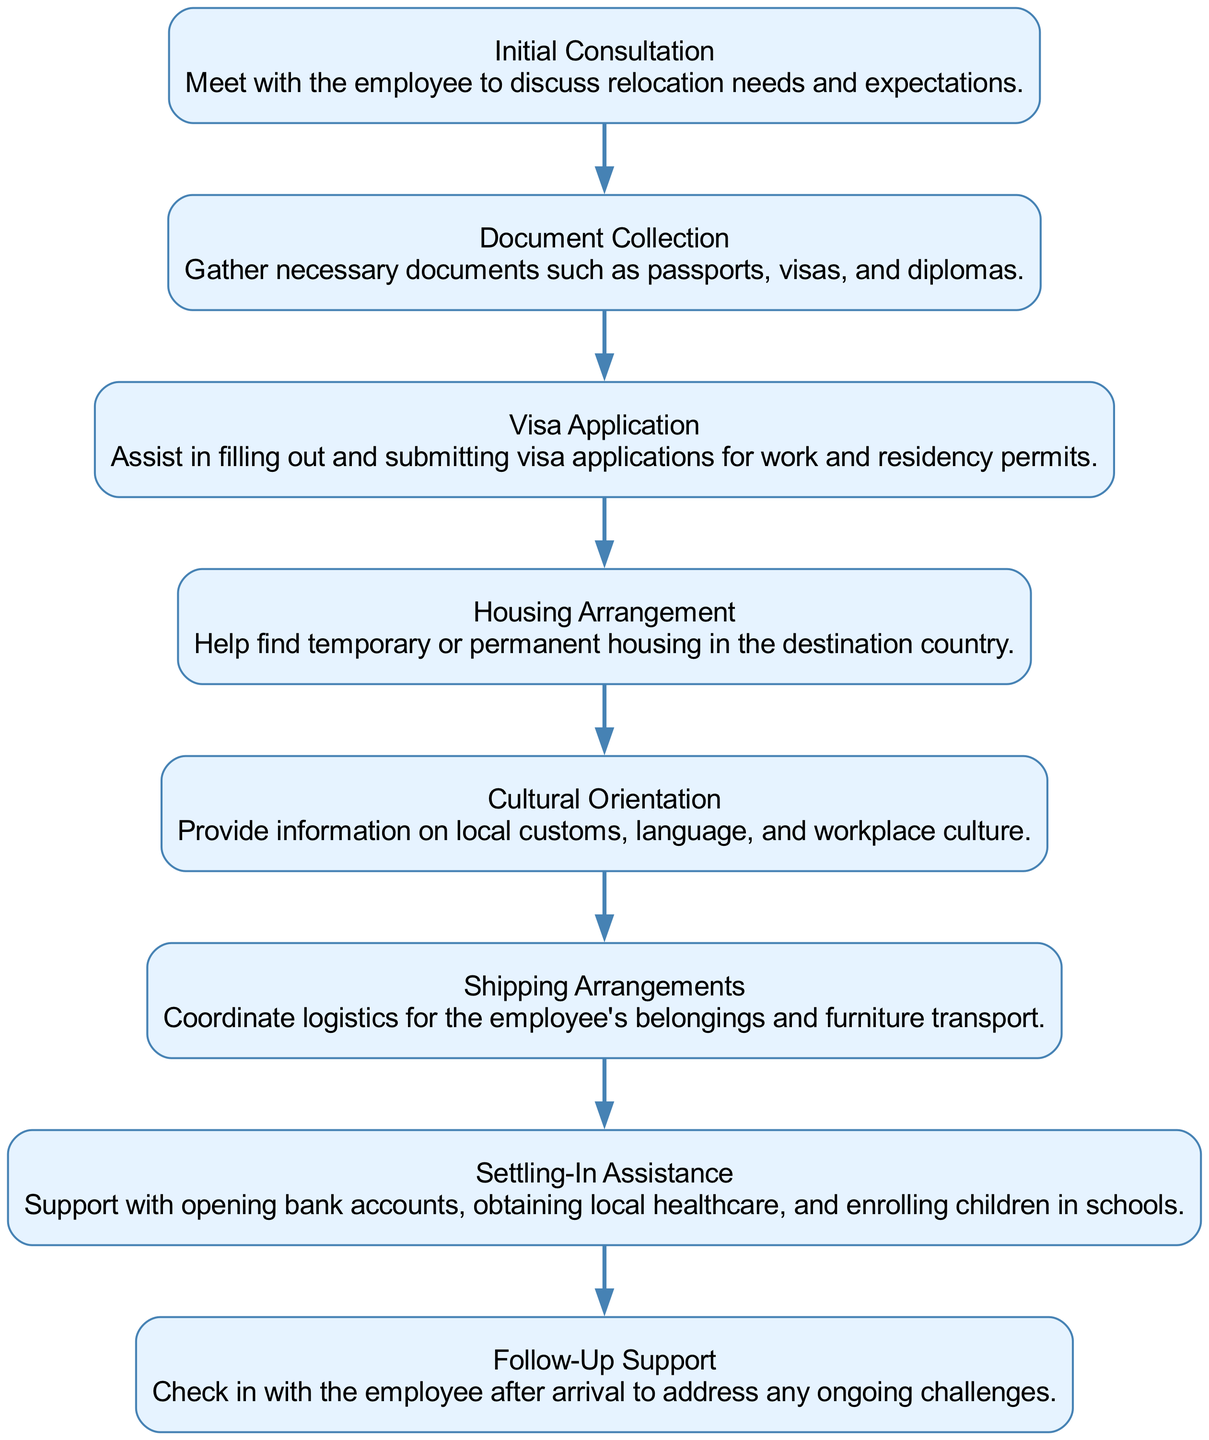What is the first step in the relocation process pipeline? The diagram starts with the first node labeled "Initial Consultation." This is the first step listed in the relocation process.
Answer: Initial Consultation How many total steps are in the relocation process? By counting the nodes in the diagram, we find there are eight distinct steps listed, from "Initial Consultation" to "Follow-Up Support."
Answer: 8 Which step follows the "Visa Application"? In the diagram, the "Visa Application" step is connected to the next node labeled "Housing Arrangement." This indicates the sequential flow of the process.
Answer: Housing Arrangement What is included in the "Settling-In Assistance"? The description under the "Settling-In Assistance" node mentions supporting opening bank accounts, obtaining local healthcare, and enrolling children in schools. Therefore, it includes several essential services for the employee.
Answer: Opening bank accounts, obtaining local healthcare, enrolling in schools What is the last step of the relocation process pipeline? Looking at the final node in the diagram, we see it is labeled "Follow-Up Support," indicating that this is where the process concludes.
Answer: Follow-Up Support What step provides cultural information about the destination? Reviewing the nodes, the "Cultural Orientation" step is specifically designed to provide information about local customs, language, and workplace culture, according to the description.
Answer: Cultural Orientation Which step assists with logistics for the employee's belongings? The diagram identifies the "Shipping Arrangements" step as the one coordinating logistics for transporting the employee's belongings and furniture, based on its label and description.
Answer: Shipping Arrangements Is there any step that provides ongoing support after arrival? The diagram explicitly contains a step called "Follow-Up Support," which signifies that this step is focused on offering ongoing assistance after the employee has arrived in the new country.
Answer: Follow-Up Support 